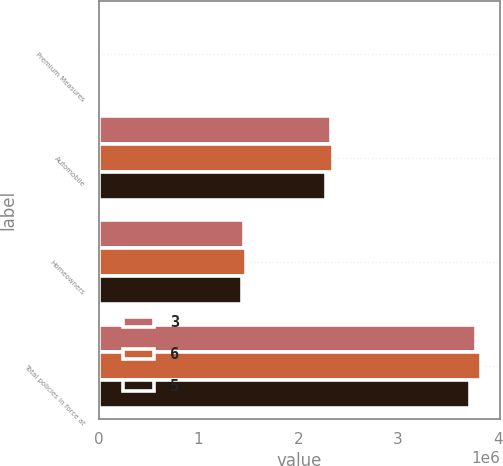Convert chart to OTSL. <chart><loc_0><loc_0><loc_500><loc_500><stacked_bar_chart><ecel><fcel>Premium Measures<fcel>Automobile<fcel>Homeowners<fcel>Total policies in force at<nl><fcel>3<fcel>2008<fcel>2.32388e+06<fcel>1.45595e+06<fcel>3.77984e+06<nl><fcel>6<fcel>2007<fcel>2.3494e+06<fcel>1.48154e+06<fcel>3.83094e+06<nl><fcel>5<fcel>2006<fcel>2.27616e+06<fcel>1.4404e+06<fcel>3.71656e+06<nl></chart> 